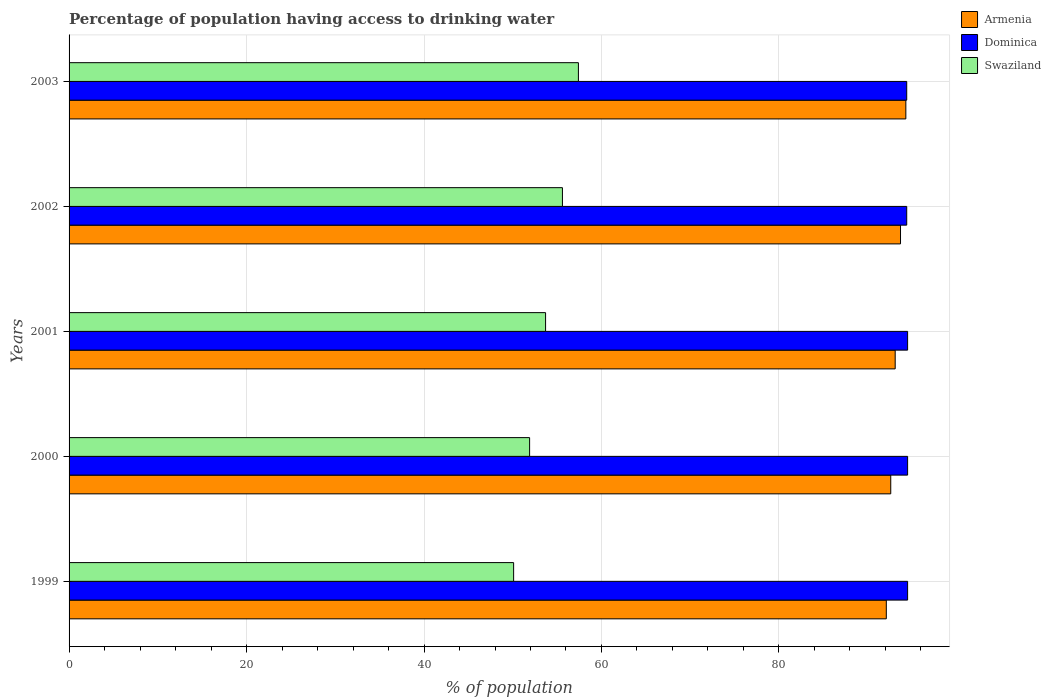How many different coloured bars are there?
Keep it short and to the point. 3. How many groups of bars are there?
Your answer should be compact. 5. How many bars are there on the 3rd tick from the top?
Make the answer very short. 3. How many bars are there on the 1st tick from the bottom?
Ensure brevity in your answer.  3. What is the percentage of population having access to drinking water in Dominica in 2000?
Provide a succinct answer. 94.5. Across all years, what is the maximum percentage of population having access to drinking water in Swaziland?
Make the answer very short. 57.4. Across all years, what is the minimum percentage of population having access to drinking water in Armenia?
Keep it short and to the point. 92.1. What is the total percentage of population having access to drinking water in Swaziland in the graph?
Make the answer very short. 268.7. What is the difference between the percentage of population having access to drinking water in Swaziland in 1999 and that in 2000?
Ensure brevity in your answer.  -1.8. What is the difference between the percentage of population having access to drinking water in Swaziland in 2000 and the percentage of population having access to drinking water in Dominica in 2001?
Offer a terse response. -42.6. What is the average percentage of population having access to drinking water in Swaziland per year?
Provide a short and direct response. 53.74. In the year 2002, what is the difference between the percentage of population having access to drinking water in Dominica and percentage of population having access to drinking water in Swaziland?
Your answer should be compact. 38.8. In how many years, is the percentage of population having access to drinking water in Swaziland greater than 8 %?
Offer a very short reply. 5. What is the ratio of the percentage of population having access to drinking water in Dominica in 1999 to that in 2003?
Make the answer very short. 1. What is the difference between the highest and the lowest percentage of population having access to drinking water in Armenia?
Make the answer very short. 2.2. In how many years, is the percentage of population having access to drinking water in Armenia greater than the average percentage of population having access to drinking water in Armenia taken over all years?
Keep it short and to the point. 2. Is the sum of the percentage of population having access to drinking water in Armenia in 2000 and 2001 greater than the maximum percentage of population having access to drinking water in Dominica across all years?
Make the answer very short. Yes. What does the 2nd bar from the top in 2000 represents?
Your answer should be very brief. Dominica. What does the 2nd bar from the bottom in 2003 represents?
Offer a terse response. Dominica. Is it the case that in every year, the sum of the percentage of population having access to drinking water in Swaziland and percentage of population having access to drinking water in Dominica is greater than the percentage of population having access to drinking water in Armenia?
Offer a terse response. Yes. Does the graph contain any zero values?
Your answer should be very brief. No. How many legend labels are there?
Your answer should be very brief. 3. What is the title of the graph?
Ensure brevity in your answer.  Percentage of population having access to drinking water. What is the label or title of the X-axis?
Provide a short and direct response. % of population. What is the label or title of the Y-axis?
Offer a very short reply. Years. What is the % of population in Armenia in 1999?
Your answer should be very brief. 92.1. What is the % of population of Dominica in 1999?
Ensure brevity in your answer.  94.5. What is the % of population of Swaziland in 1999?
Offer a very short reply. 50.1. What is the % of population in Armenia in 2000?
Provide a short and direct response. 92.6. What is the % of population in Dominica in 2000?
Give a very brief answer. 94.5. What is the % of population of Swaziland in 2000?
Make the answer very short. 51.9. What is the % of population in Armenia in 2001?
Provide a succinct answer. 93.1. What is the % of population in Dominica in 2001?
Provide a short and direct response. 94.5. What is the % of population of Swaziland in 2001?
Make the answer very short. 53.7. What is the % of population of Armenia in 2002?
Offer a terse response. 93.7. What is the % of population in Dominica in 2002?
Provide a short and direct response. 94.4. What is the % of population of Swaziland in 2002?
Offer a terse response. 55.6. What is the % of population of Armenia in 2003?
Your answer should be compact. 94.3. What is the % of population of Dominica in 2003?
Give a very brief answer. 94.4. What is the % of population in Swaziland in 2003?
Keep it short and to the point. 57.4. Across all years, what is the maximum % of population of Armenia?
Offer a very short reply. 94.3. Across all years, what is the maximum % of population in Dominica?
Provide a succinct answer. 94.5. Across all years, what is the maximum % of population in Swaziland?
Offer a terse response. 57.4. Across all years, what is the minimum % of population in Armenia?
Your response must be concise. 92.1. Across all years, what is the minimum % of population in Dominica?
Offer a terse response. 94.4. Across all years, what is the minimum % of population of Swaziland?
Ensure brevity in your answer.  50.1. What is the total % of population of Armenia in the graph?
Offer a terse response. 465.8. What is the total % of population in Dominica in the graph?
Your response must be concise. 472.3. What is the total % of population in Swaziland in the graph?
Keep it short and to the point. 268.7. What is the difference between the % of population of Dominica in 1999 and that in 2000?
Make the answer very short. 0. What is the difference between the % of population in Dominica in 1999 and that in 2001?
Offer a very short reply. 0. What is the difference between the % of population of Dominica in 1999 and that in 2002?
Provide a short and direct response. 0.1. What is the difference between the % of population in Armenia in 1999 and that in 2003?
Ensure brevity in your answer.  -2.2. What is the difference between the % of population in Dominica in 1999 and that in 2003?
Your answer should be very brief. 0.1. What is the difference between the % of population of Swaziland in 1999 and that in 2003?
Give a very brief answer. -7.3. What is the difference between the % of population of Dominica in 2000 and that in 2002?
Offer a very short reply. 0.1. What is the difference between the % of population of Swaziland in 2000 and that in 2002?
Offer a very short reply. -3.7. What is the difference between the % of population in Armenia in 2000 and that in 2003?
Give a very brief answer. -1.7. What is the difference between the % of population of Dominica in 2000 and that in 2003?
Keep it short and to the point. 0.1. What is the difference between the % of population in Swaziland in 2000 and that in 2003?
Make the answer very short. -5.5. What is the difference between the % of population of Armenia in 2001 and that in 2002?
Your answer should be compact. -0.6. What is the difference between the % of population in Dominica in 2001 and that in 2002?
Ensure brevity in your answer.  0.1. What is the difference between the % of population of Swaziland in 2001 and that in 2002?
Ensure brevity in your answer.  -1.9. What is the difference between the % of population of Armenia in 2001 and that in 2003?
Your response must be concise. -1.2. What is the difference between the % of population of Dominica in 2001 and that in 2003?
Your answer should be very brief. 0.1. What is the difference between the % of population of Swaziland in 2002 and that in 2003?
Keep it short and to the point. -1.8. What is the difference between the % of population of Armenia in 1999 and the % of population of Dominica in 2000?
Offer a very short reply. -2.4. What is the difference between the % of population of Armenia in 1999 and the % of population of Swaziland in 2000?
Ensure brevity in your answer.  40.2. What is the difference between the % of population in Dominica in 1999 and the % of population in Swaziland in 2000?
Provide a short and direct response. 42.6. What is the difference between the % of population of Armenia in 1999 and the % of population of Dominica in 2001?
Make the answer very short. -2.4. What is the difference between the % of population of Armenia in 1999 and the % of population of Swaziland in 2001?
Ensure brevity in your answer.  38.4. What is the difference between the % of population in Dominica in 1999 and the % of population in Swaziland in 2001?
Offer a very short reply. 40.8. What is the difference between the % of population in Armenia in 1999 and the % of population in Dominica in 2002?
Offer a terse response. -2.3. What is the difference between the % of population of Armenia in 1999 and the % of population of Swaziland in 2002?
Give a very brief answer. 36.5. What is the difference between the % of population of Dominica in 1999 and the % of population of Swaziland in 2002?
Provide a succinct answer. 38.9. What is the difference between the % of population of Armenia in 1999 and the % of population of Dominica in 2003?
Offer a terse response. -2.3. What is the difference between the % of population of Armenia in 1999 and the % of population of Swaziland in 2003?
Provide a succinct answer. 34.7. What is the difference between the % of population of Dominica in 1999 and the % of population of Swaziland in 2003?
Give a very brief answer. 37.1. What is the difference between the % of population of Armenia in 2000 and the % of population of Swaziland in 2001?
Give a very brief answer. 38.9. What is the difference between the % of population in Dominica in 2000 and the % of population in Swaziland in 2001?
Your response must be concise. 40.8. What is the difference between the % of population in Dominica in 2000 and the % of population in Swaziland in 2002?
Offer a very short reply. 38.9. What is the difference between the % of population in Armenia in 2000 and the % of population in Swaziland in 2003?
Provide a succinct answer. 35.2. What is the difference between the % of population in Dominica in 2000 and the % of population in Swaziland in 2003?
Your response must be concise. 37.1. What is the difference between the % of population in Armenia in 2001 and the % of population in Swaziland in 2002?
Your answer should be very brief. 37.5. What is the difference between the % of population in Dominica in 2001 and the % of population in Swaziland in 2002?
Ensure brevity in your answer.  38.9. What is the difference between the % of population in Armenia in 2001 and the % of population in Dominica in 2003?
Provide a succinct answer. -1.3. What is the difference between the % of population of Armenia in 2001 and the % of population of Swaziland in 2003?
Your answer should be very brief. 35.7. What is the difference between the % of population of Dominica in 2001 and the % of population of Swaziland in 2003?
Keep it short and to the point. 37.1. What is the difference between the % of population in Armenia in 2002 and the % of population in Dominica in 2003?
Make the answer very short. -0.7. What is the difference between the % of population of Armenia in 2002 and the % of population of Swaziland in 2003?
Give a very brief answer. 36.3. What is the average % of population of Armenia per year?
Provide a succinct answer. 93.16. What is the average % of population of Dominica per year?
Make the answer very short. 94.46. What is the average % of population in Swaziland per year?
Provide a short and direct response. 53.74. In the year 1999, what is the difference between the % of population in Armenia and % of population in Swaziland?
Your response must be concise. 42. In the year 1999, what is the difference between the % of population of Dominica and % of population of Swaziland?
Your answer should be compact. 44.4. In the year 2000, what is the difference between the % of population of Armenia and % of population of Swaziland?
Make the answer very short. 40.7. In the year 2000, what is the difference between the % of population in Dominica and % of population in Swaziland?
Your answer should be compact. 42.6. In the year 2001, what is the difference between the % of population in Armenia and % of population in Swaziland?
Offer a very short reply. 39.4. In the year 2001, what is the difference between the % of population in Dominica and % of population in Swaziland?
Give a very brief answer. 40.8. In the year 2002, what is the difference between the % of population in Armenia and % of population in Dominica?
Offer a very short reply. -0.7. In the year 2002, what is the difference between the % of population of Armenia and % of population of Swaziland?
Ensure brevity in your answer.  38.1. In the year 2002, what is the difference between the % of population of Dominica and % of population of Swaziland?
Your answer should be compact. 38.8. In the year 2003, what is the difference between the % of population in Armenia and % of population in Swaziland?
Provide a succinct answer. 36.9. In the year 2003, what is the difference between the % of population of Dominica and % of population of Swaziland?
Your answer should be very brief. 37. What is the ratio of the % of population of Armenia in 1999 to that in 2000?
Provide a succinct answer. 0.99. What is the ratio of the % of population in Swaziland in 1999 to that in 2000?
Keep it short and to the point. 0.97. What is the ratio of the % of population of Armenia in 1999 to that in 2001?
Your answer should be compact. 0.99. What is the ratio of the % of population in Swaziland in 1999 to that in 2001?
Provide a short and direct response. 0.93. What is the ratio of the % of population of Armenia in 1999 to that in 2002?
Your answer should be compact. 0.98. What is the ratio of the % of population in Dominica in 1999 to that in 2002?
Provide a short and direct response. 1. What is the ratio of the % of population of Swaziland in 1999 to that in 2002?
Your answer should be compact. 0.9. What is the ratio of the % of population of Armenia in 1999 to that in 2003?
Offer a terse response. 0.98. What is the ratio of the % of population of Dominica in 1999 to that in 2003?
Offer a very short reply. 1. What is the ratio of the % of population of Swaziland in 1999 to that in 2003?
Give a very brief answer. 0.87. What is the ratio of the % of population in Armenia in 2000 to that in 2001?
Your response must be concise. 0.99. What is the ratio of the % of population in Dominica in 2000 to that in 2001?
Your response must be concise. 1. What is the ratio of the % of population of Swaziland in 2000 to that in 2001?
Give a very brief answer. 0.97. What is the ratio of the % of population in Armenia in 2000 to that in 2002?
Your answer should be very brief. 0.99. What is the ratio of the % of population of Swaziland in 2000 to that in 2002?
Provide a short and direct response. 0.93. What is the ratio of the % of population of Armenia in 2000 to that in 2003?
Your answer should be compact. 0.98. What is the ratio of the % of population of Swaziland in 2000 to that in 2003?
Your answer should be compact. 0.9. What is the ratio of the % of population of Swaziland in 2001 to that in 2002?
Offer a very short reply. 0.97. What is the ratio of the % of population in Armenia in 2001 to that in 2003?
Provide a short and direct response. 0.99. What is the ratio of the % of population of Dominica in 2001 to that in 2003?
Your answer should be compact. 1. What is the ratio of the % of population in Swaziland in 2001 to that in 2003?
Provide a succinct answer. 0.94. What is the ratio of the % of population in Armenia in 2002 to that in 2003?
Offer a very short reply. 0.99. What is the ratio of the % of population in Dominica in 2002 to that in 2003?
Your answer should be compact. 1. What is the ratio of the % of population of Swaziland in 2002 to that in 2003?
Offer a very short reply. 0.97. What is the difference between the highest and the second highest % of population of Swaziland?
Your answer should be compact. 1.8. What is the difference between the highest and the lowest % of population in Armenia?
Provide a succinct answer. 2.2. What is the difference between the highest and the lowest % of population of Swaziland?
Provide a succinct answer. 7.3. 